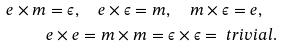Convert formula to latex. <formula><loc_0><loc_0><loc_500><loc_500>e \times m & = \epsilon , \quad e \times \epsilon = m , \quad m \times \epsilon = e , \\ & e \times e = m \times m = \epsilon \times \epsilon = \ t r i v i a l .</formula> 